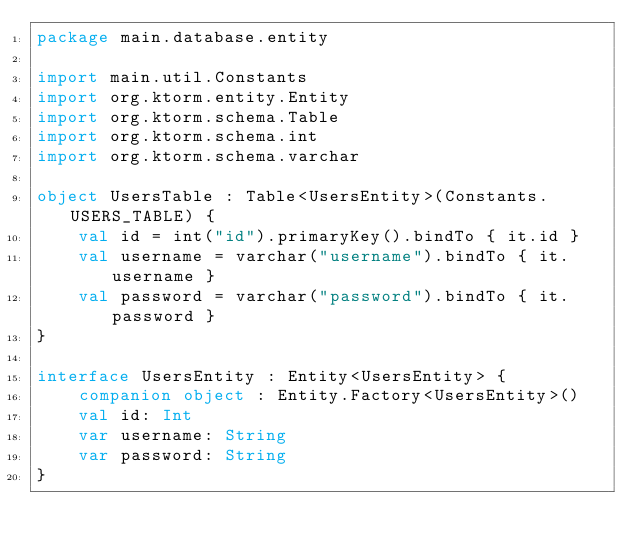Convert code to text. <code><loc_0><loc_0><loc_500><loc_500><_Kotlin_>package main.database.entity

import main.util.Constants
import org.ktorm.entity.Entity
import org.ktorm.schema.Table
import org.ktorm.schema.int
import org.ktorm.schema.varchar

object UsersTable : Table<UsersEntity>(Constants.USERS_TABLE) {
    val id = int("id").primaryKey().bindTo { it.id }
    val username = varchar("username").bindTo { it.username }
    val password = varchar("password").bindTo { it.password }
}

interface UsersEntity : Entity<UsersEntity> {
    companion object : Entity.Factory<UsersEntity>()
    val id: Int
    var username: String
    var password: String
}</code> 